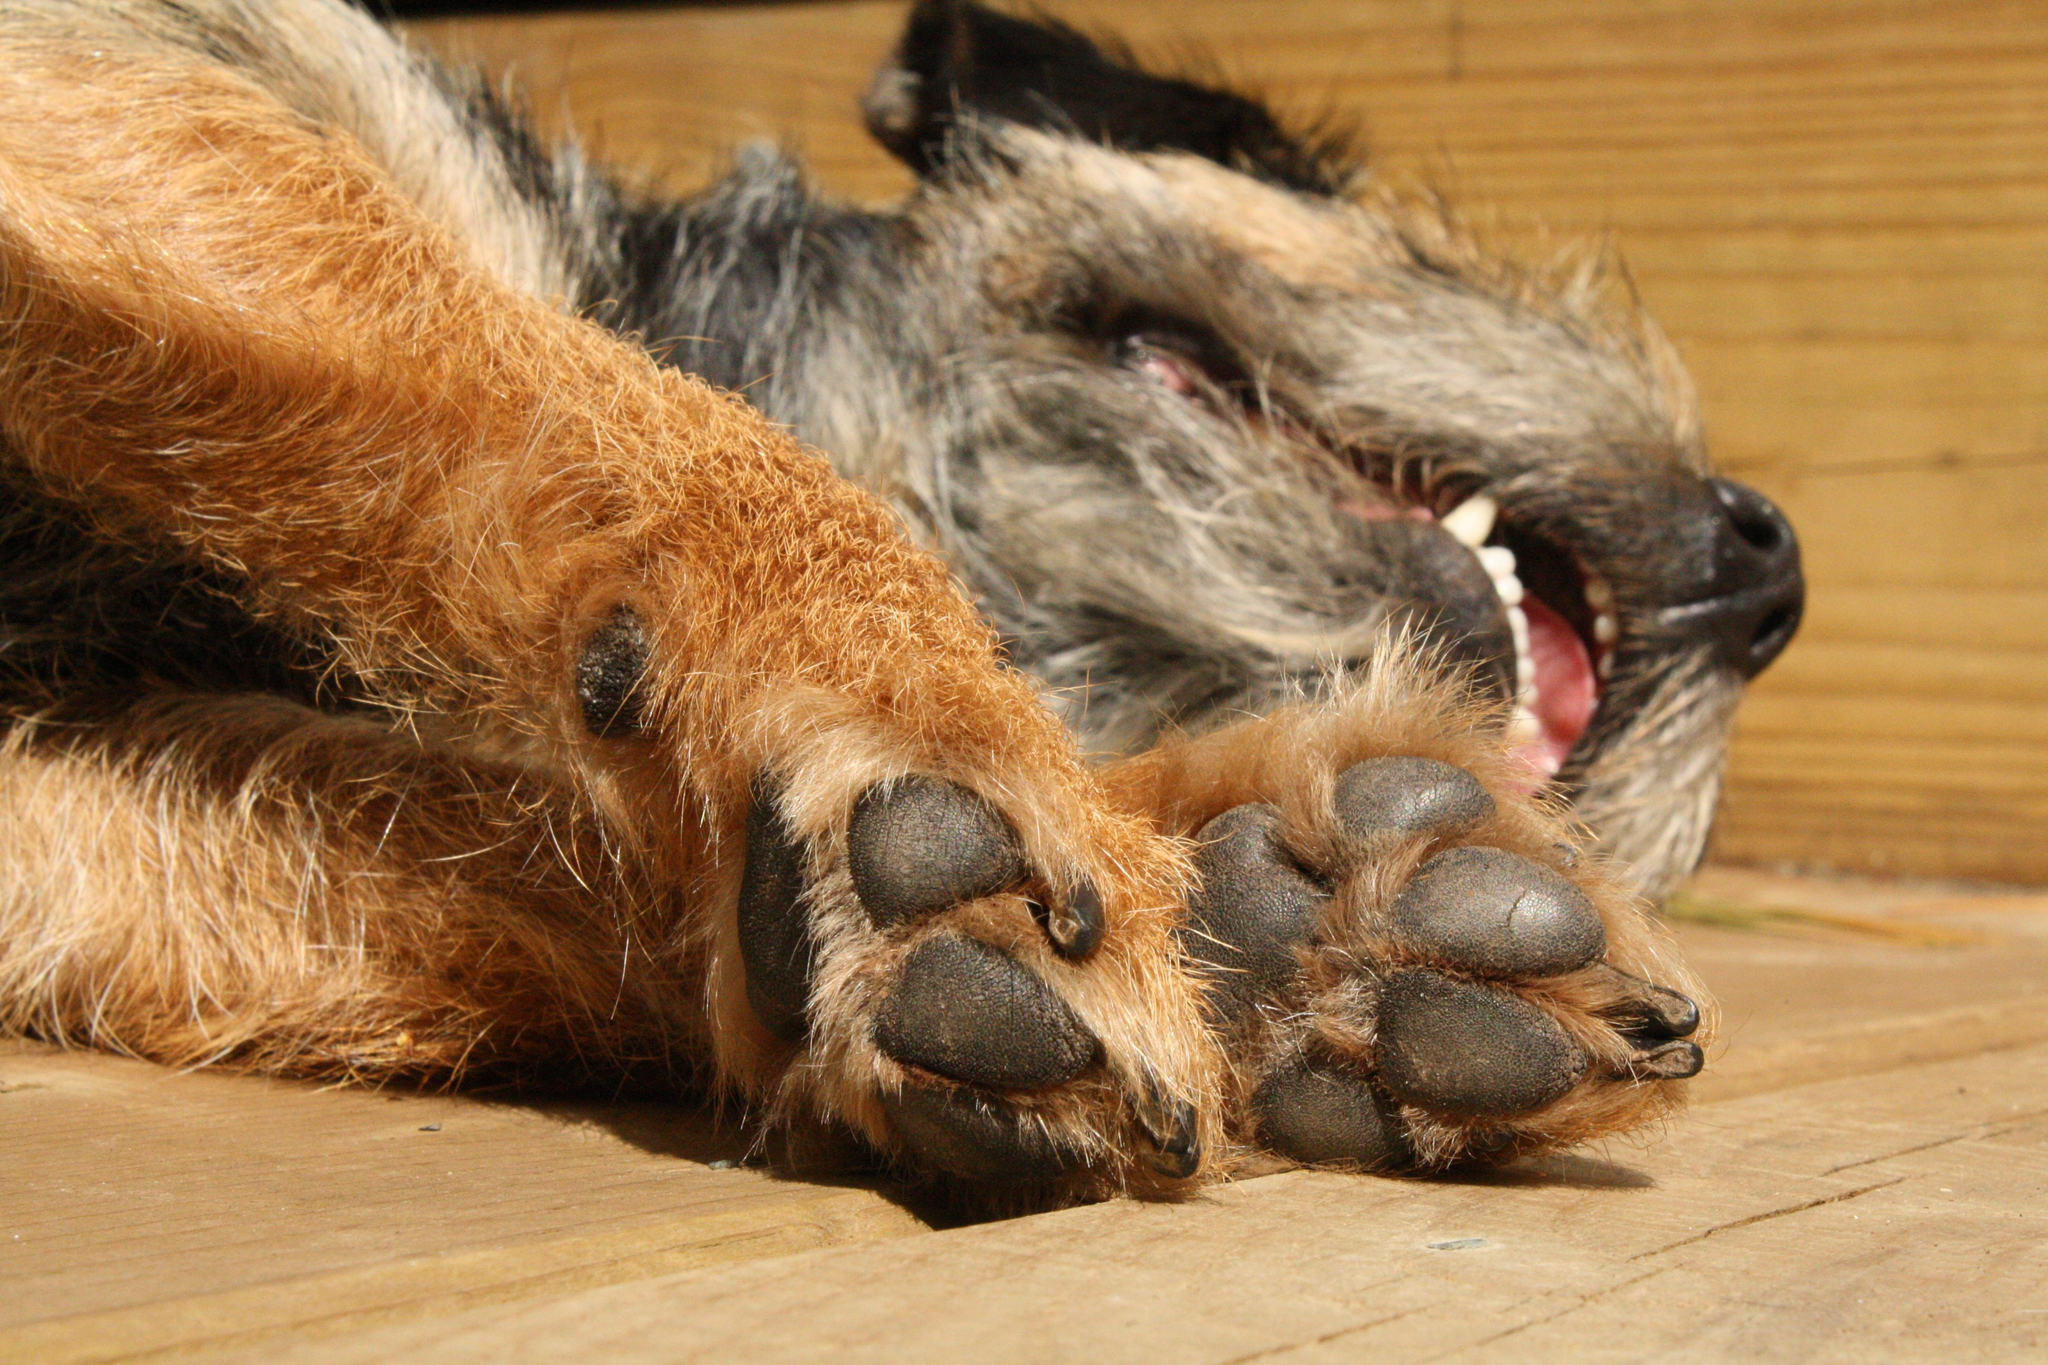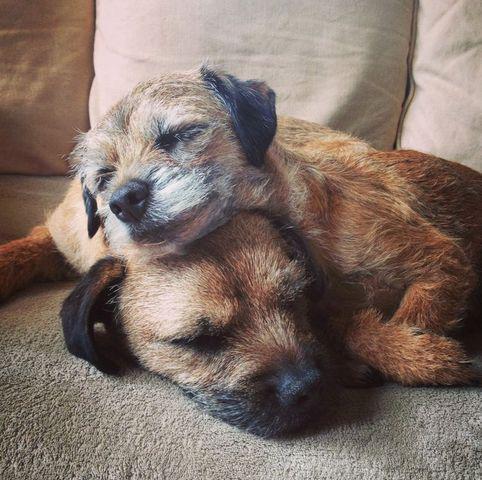The first image is the image on the left, the second image is the image on the right. Evaluate the accuracy of this statement regarding the images: "There is only one dog in each picture.". Is it true? Answer yes or no. No. The first image is the image on the left, the second image is the image on the right. Assess this claim about the two images: "One image shows two dogs with their heads close together.". Correct or not? Answer yes or no. Yes. 